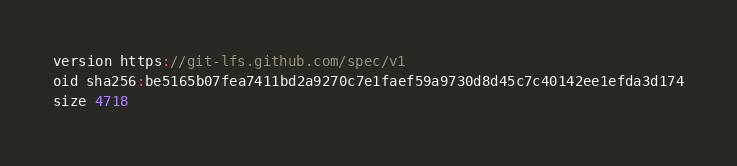Convert code to text. <code><loc_0><loc_0><loc_500><loc_500><_C_>version https://git-lfs.github.com/spec/v1
oid sha256:be5165b07fea7411bd2a9270c7e1faef59a9730d8d45c7c40142ee1efda3d174
size 4718
</code> 